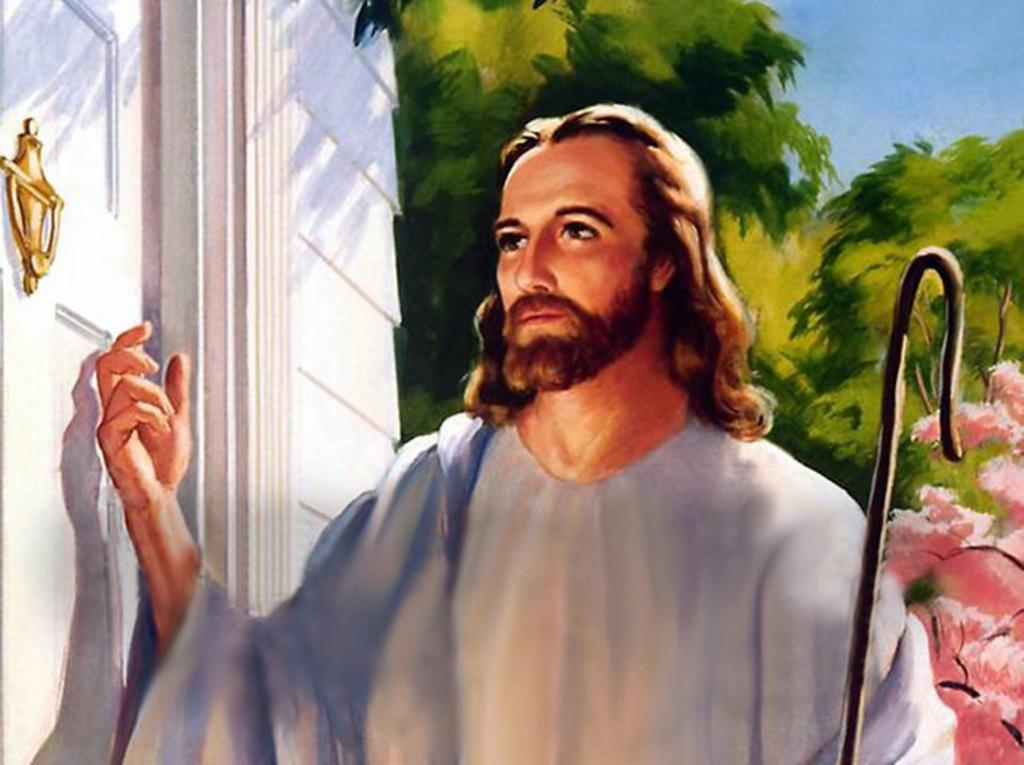What is the main subject of the image? There is a painting in the image. What can be seen in the painting? The painting contains a person. What type of natural scenery is visible in the image? There are trees visible in the image. What architectural feature can be seen in the image? There is a door in the image. What type of knife is being used to take a picture of the person in the painting? There is no knife or camera present in the image; it only contains a painting with a person and trees, as well as a door. 